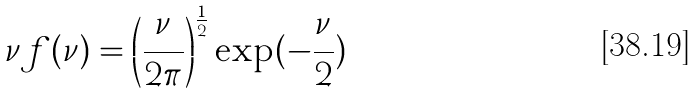<formula> <loc_0><loc_0><loc_500><loc_500>\nu f ( \nu ) = \left ( \frac { \nu } { 2 \pi } \right ) ^ { \frac { 1 } { 2 } } \exp ( - \frac { \nu } { 2 } )</formula> 